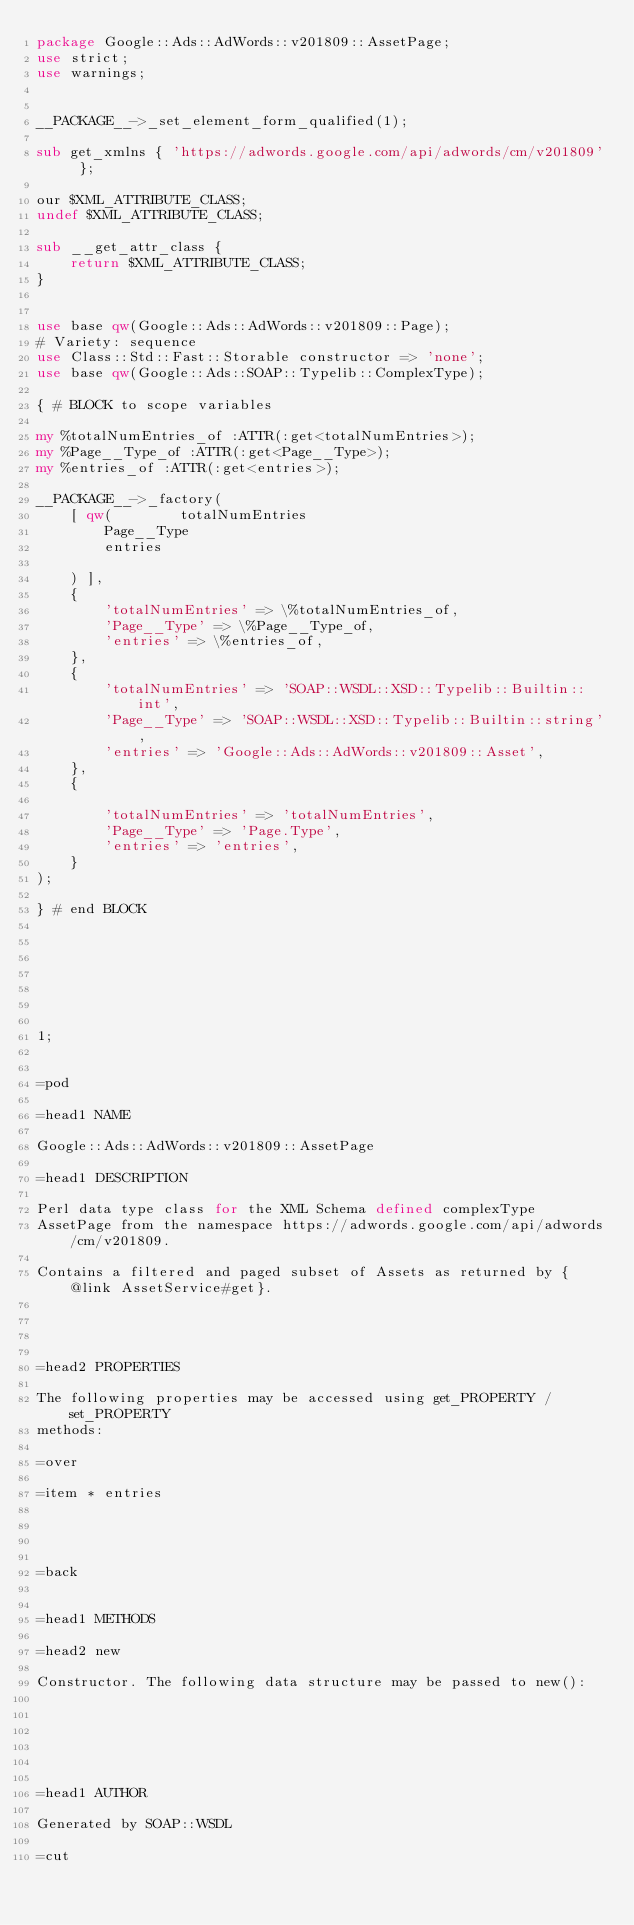Convert code to text. <code><loc_0><loc_0><loc_500><loc_500><_Perl_>package Google::Ads::AdWords::v201809::AssetPage;
use strict;
use warnings;


__PACKAGE__->_set_element_form_qualified(1);

sub get_xmlns { 'https://adwords.google.com/api/adwords/cm/v201809' };

our $XML_ATTRIBUTE_CLASS;
undef $XML_ATTRIBUTE_CLASS;

sub __get_attr_class {
    return $XML_ATTRIBUTE_CLASS;
}


use base qw(Google::Ads::AdWords::v201809::Page);
# Variety: sequence
use Class::Std::Fast::Storable constructor => 'none';
use base qw(Google::Ads::SOAP::Typelib::ComplexType);

{ # BLOCK to scope variables

my %totalNumEntries_of :ATTR(:get<totalNumEntries>);
my %Page__Type_of :ATTR(:get<Page__Type>);
my %entries_of :ATTR(:get<entries>);

__PACKAGE__->_factory(
    [ qw(        totalNumEntries
        Page__Type
        entries

    ) ],
    {
        'totalNumEntries' => \%totalNumEntries_of,
        'Page__Type' => \%Page__Type_of,
        'entries' => \%entries_of,
    },
    {
        'totalNumEntries' => 'SOAP::WSDL::XSD::Typelib::Builtin::int',
        'Page__Type' => 'SOAP::WSDL::XSD::Typelib::Builtin::string',
        'entries' => 'Google::Ads::AdWords::v201809::Asset',
    },
    {

        'totalNumEntries' => 'totalNumEntries',
        'Page__Type' => 'Page.Type',
        'entries' => 'entries',
    }
);

} # end BLOCK







1;


=pod

=head1 NAME

Google::Ads::AdWords::v201809::AssetPage

=head1 DESCRIPTION

Perl data type class for the XML Schema defined complexType
AssetPage from the namespace https://adwords.google.com/api/adwords/cm/v201809.

Contains a filtered and paged subset of Assets as returned by {@link AssetService#get}. 




=head2 PROPERTIES

The following properties may be accessed using get_PROPERTY / set_PROPERTY
methods:

=over

=item * entries




=back


=head1 METHODS

=head2 new

Constructor. The following data structure may be passed to new():






=head1 AUTHOR

Generated by SOAP::WSDL

=cut

</code> 